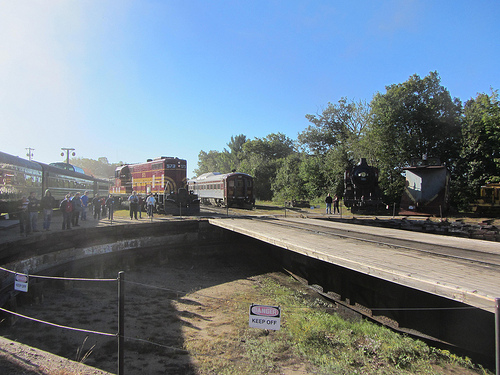What is the color of the train in the middle of the image? The train in the middle of the image is red, adding a vibrant contrast to the scene. 